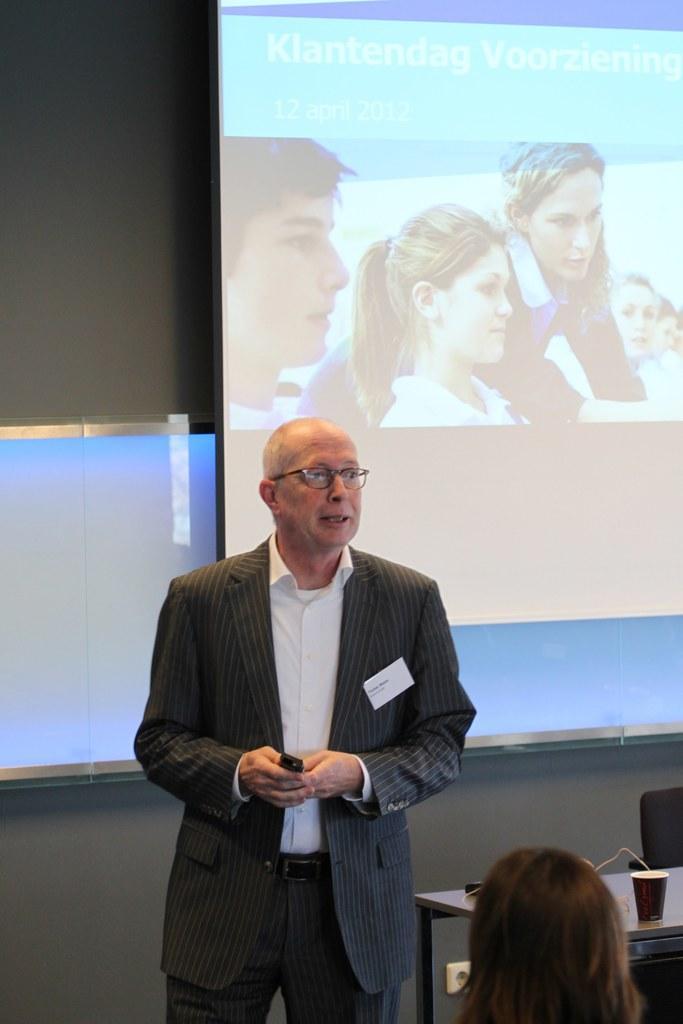In one or two sentences, can you explain what this image depicts? In this image we can see a man standing on the floor. He is wearing a suit and he is holding a remote in his hands. Here we can see the head of a person on the bottom right side. Here we can see the wooden table. Here we can see a cup on the table. In the background, we can see the screen. 